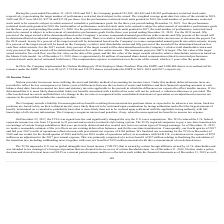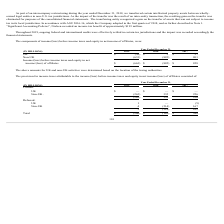According to Nielsen Nv's financial document, What was the income tax benefit recorded by Nielsen when the Company adopted ASU 2016-16? According to the financial document, $193 million. The relevant text states: "en recorded an income tax benefit of approximately $193 million...." Also, What is the amount of UK income loss before income taxes and equity in net income of affiliates for the year ended December 31, 2019? According to the financial document, 30 (in millions). The relevant text states: "UK $ (30) $ 3 $ 27..." Also, What is the amount of non-UK  income loss before income taxes and equity in net income of affiliates for the year ended December 31, 2018? According to the financial document, 885 (in millions). The relevant text states: "Non-UK (633) (885) 801..." Also, can you calculate: What is the percentage change in the loss before income taxes and equity in net income/(loss) of affiliates from 2018 to 2019? To answer this question, I need to perform calculations using the financial data. The calculation is: (663-882)/882, which equals -24.83 (percentage). This is based on the information: "and equity in net income/(loss) of affiliates $ (663) $ (882) $ 828 ity in net income/(loss) of affiliates $ (663) $ (882) $ 828..." The key data points involved are: 663, 882. Also, can you calculate: What is the percentage of non-UK activities in loss before income taxes and equity in net loss of affiliates for the year ended December 31, 2019? Based on the calculation: 633/663, the result is 95.48 (percentage). This is based on the information: "Non-UK (633) (885) 801 and equity in net income/(loss) of affiliates $ (663) $ (882) $ 828..." The key data points involved are: 633, 663. Also, can you calculate: What is the percentage change in the UK activities from 2018 to 2019? To answer this question, I need to perform calculations using the financial data. The calculation is: (-30-3)/3, which equals -1100.0 (percentage). This is based on the information: "UK $ (30) $ 3 $ 27 UK $ (30) $ 3 $ 27..." The key data points involved are: 3, 30. 